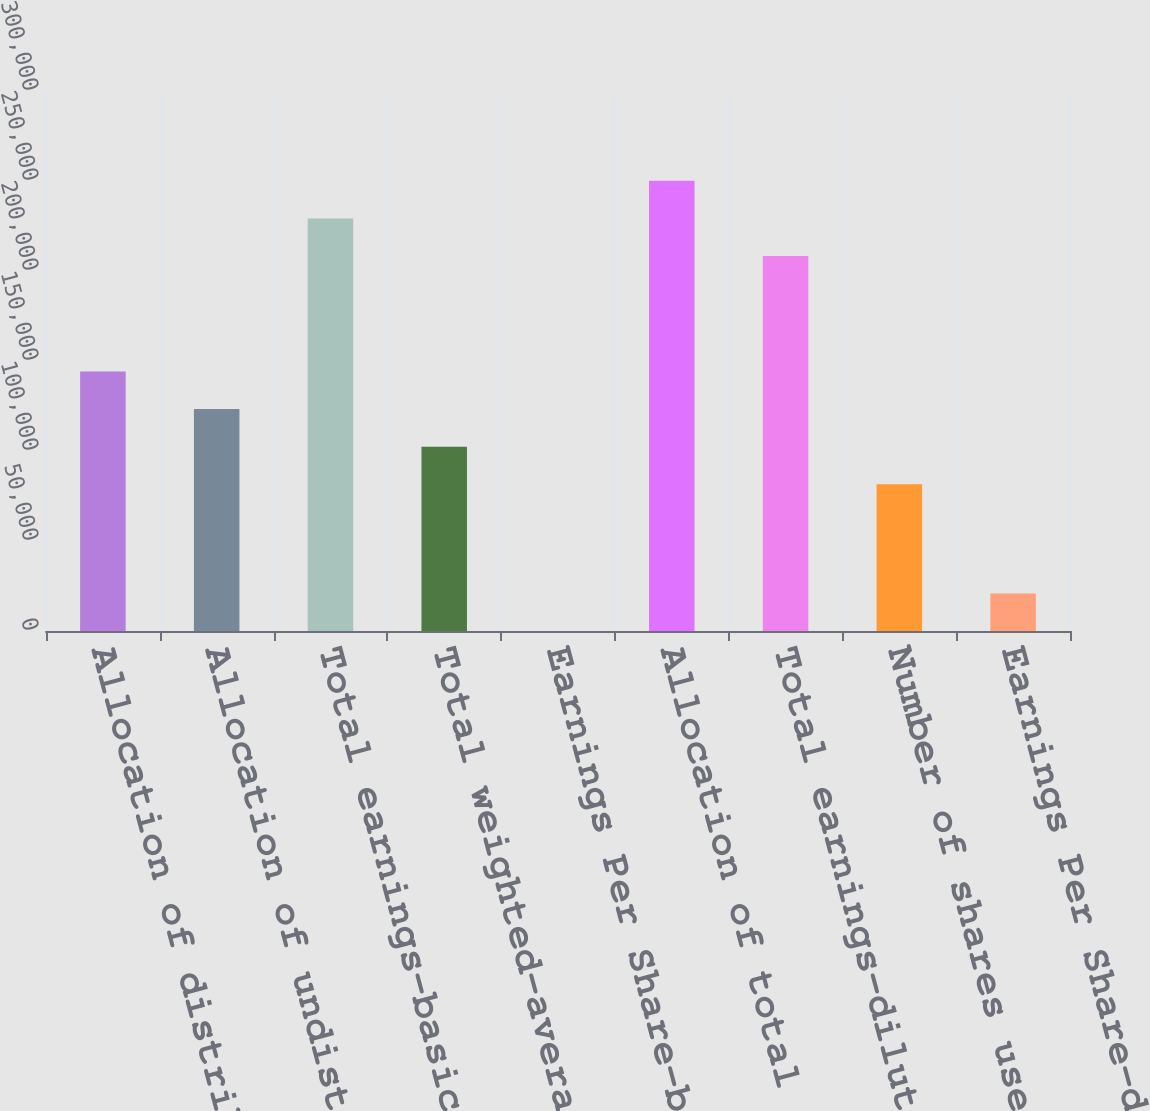<chart> <loc_0><loc_0><loc_500><loc_500><bar_chart><fcel>Allocation of distributed<fcel>Allocation of undistributed<fcel>Total earnings-basic<fcel>Total weighted-average<fcel>Earnings Per Share-basic<fcel>Allocation of total earnings<fcel>Total earnings-diluted<fcel>Number of shares used in basic<fcel>Earnings Per Share-diluted<nl><fcel>144145<fcel>123264<fcel>229206<fcel>102383<fcel>3.44<fcel>250088<fcel>208325<fcel>81501.4<fcel>20884.8<nl></chart> 